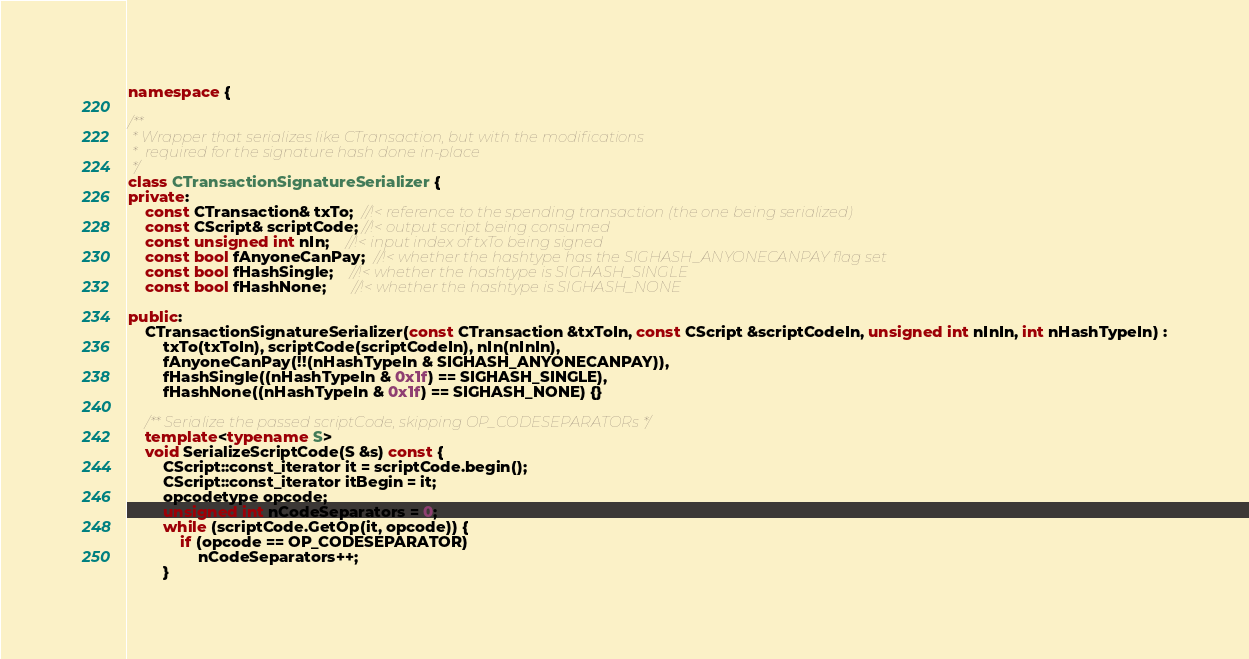Convert code to text. <code><loc_0><loc_0><loc_500><loc_500><_C++_>namespace {

/**
 * Wrapper that serializes like CTransaction, but with the modifications
 *  required for the signature hash done in-place
 */
class CTransactionSignatureSerializer {
private:
    const CTransaction& txTo;  //!< reference to the spending transaction (the one being serialized)
    const CScript& scriptCode; //!< output script being consumed
    const unsigned int nIn;    //!< input index of txTo being signed
    const bool fAnyoneCanPay;  //!< whether the hashtype has the SIGHASH_ANYONECANPAY flag set
    const bool fHashSingle;    //!< whether the hashtype is SIGHASH_SINGLE
    const bool fHashNone;      //!< whether the hashtype is SIGHASH_NONE

public:
    CTransactionSignatureSerializer(const CTransaction &txToIn, const CScript &scriptCodeIn, unsigned int nInIn, int nHashTypeIn) :
        txTo(txToIn), scriptCode(scriptCodeIn), nIn(nInIn),
        fAnyoneCanPay(!!(nHashTypeIn & SIGHASH_ANYONECANPAY)),
        fHashSingle((nHashTypeIn & 0x1f) == SIGHASH_SINGLE),
        fHashNone((nHashTypeIn & 0x1f) == SIGHASH_NONE) {}

    /** Serialize the passed scriptCode, skipping OP_CODESEPARATORs */
    template<typename S>
    void SerializeScriptCode(S &s) const {
        CScript::const_iterator it = scriptCode.begin();
        CScript::const_iterator itBegin = it;
        opcodetype opcode;
        unsigned int nCodeSeparators = 0;
        while (scriptCode.GetOp(it, opcode)) {
            if (opcode == OP_CODESEPARATOR)
                nCodeSeparators++;
        }</code> 